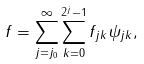<formula> <loc_0><loc_0><loc_500><loc_500>f = \sum _ { j = j _ { 0 } } ^ { \infty } \sum _ { k = 0 } ^ { 2 ^ { j } - 1 } f _ { j k } \psi _ { j k } ,</formula> 